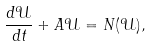<formula> <loc_0><loc_0><loc_500><loc_500>\frac { d \mathcal { U } } { d t } + A \mathcal { U } = N ( \mathcal { U } ) ,</formula> 